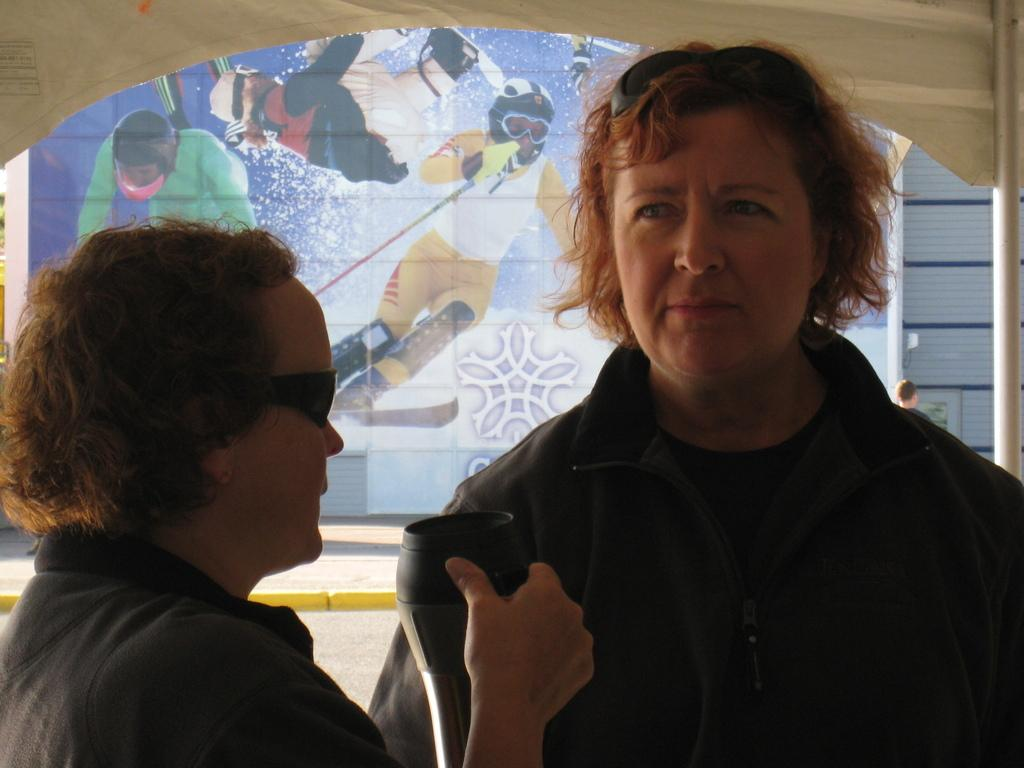How many people are in the image? There are people in the image, but the exact number is not specified. Can you describe the position of one of the people in the image? Yes, there is a person on the left side of the image. What is the person on the left side of the image doing? The person on the left side of the image is holding an object. What can be seen in the background of the image? There is a hoarding in the background of the image. What type of light is being used by the person on the right side of the image? There is no person on the right side of the image, and no light source is mentioned in the facts. 